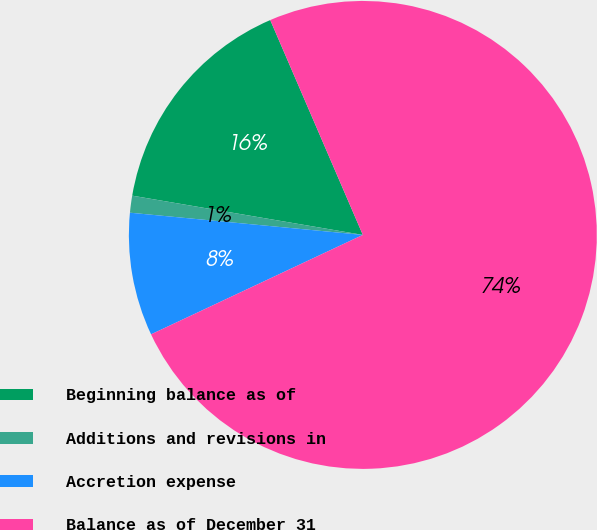Convert chart to OTSL. <chart><loc_0><loc_0><loc_500><loc_500><pie_chart><fcel>Beginning balance as of<fcel>Additions and revisions in<fcel>Accretion expense<fcel>Balance as of December 31<nl><fcel>15.84%<fcel>1.17%<fcel>8.5%<fcel>74.49%<nl></chart> 